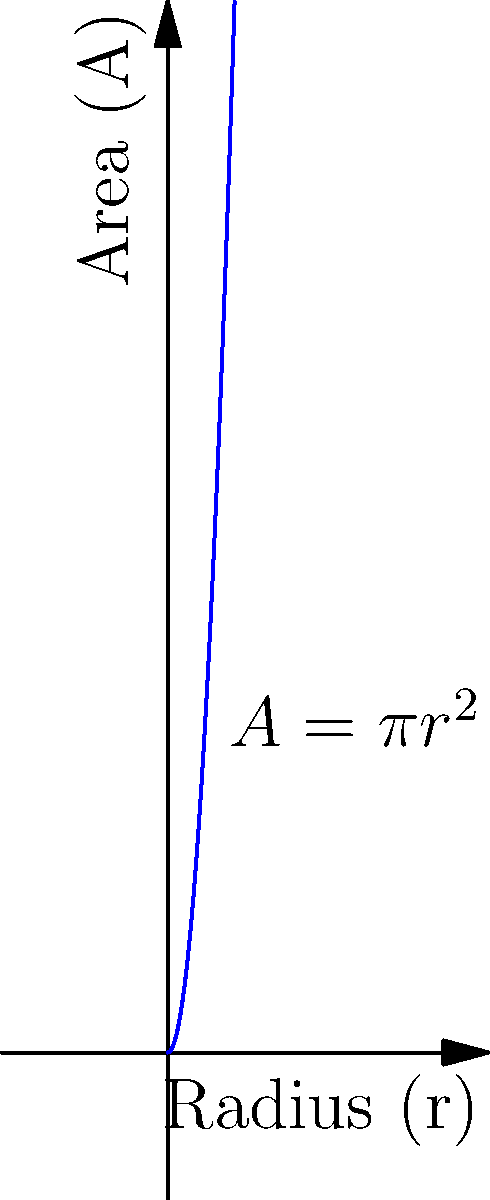In your village, you're considering creating a circular football field. As the tribal leader, you want to understand how the area changes as the radius increases. If the area $A$ of a circular field is given by the formula $A = \pi r^2$, where $r$ is the radius, what is the rate of change of the area with respect to the radius when the radius is 10 meters? To find the rate of change of the area with respect to the radius, we need to use differentiation:

1) The given formula for the area is $A = \pi r^2$

2) To find the rate of change, we need to differentiate $A$ with respect to $r$:
   $$\frac{dA}{dr} = \frac{d}{dr}(\pi r^2)$$

3) Using the power rule of differentiation:
   $$\frac{dA}{dr} = 2\pi r$$

4) This formula gives us the rate of change of area for any radius $r$.

5) We're asked to find the rate when the radius is 10 meters, so we substitute $r = 10$:
   $$\frac{dA}{dr}\bigg|_{r=10} = 2\pi(10) = 20\pi$$

6) Therefore, when the radius is 10 meters, the rate of change of the area is $20\pi$ square meters per meter of radius.

This means that for a small increase in the radius around 10 meters, the area will increase by approximately $20\pi$ square meters for each meter added to the radius.
Answer: $20\pi$ square meters per meter 